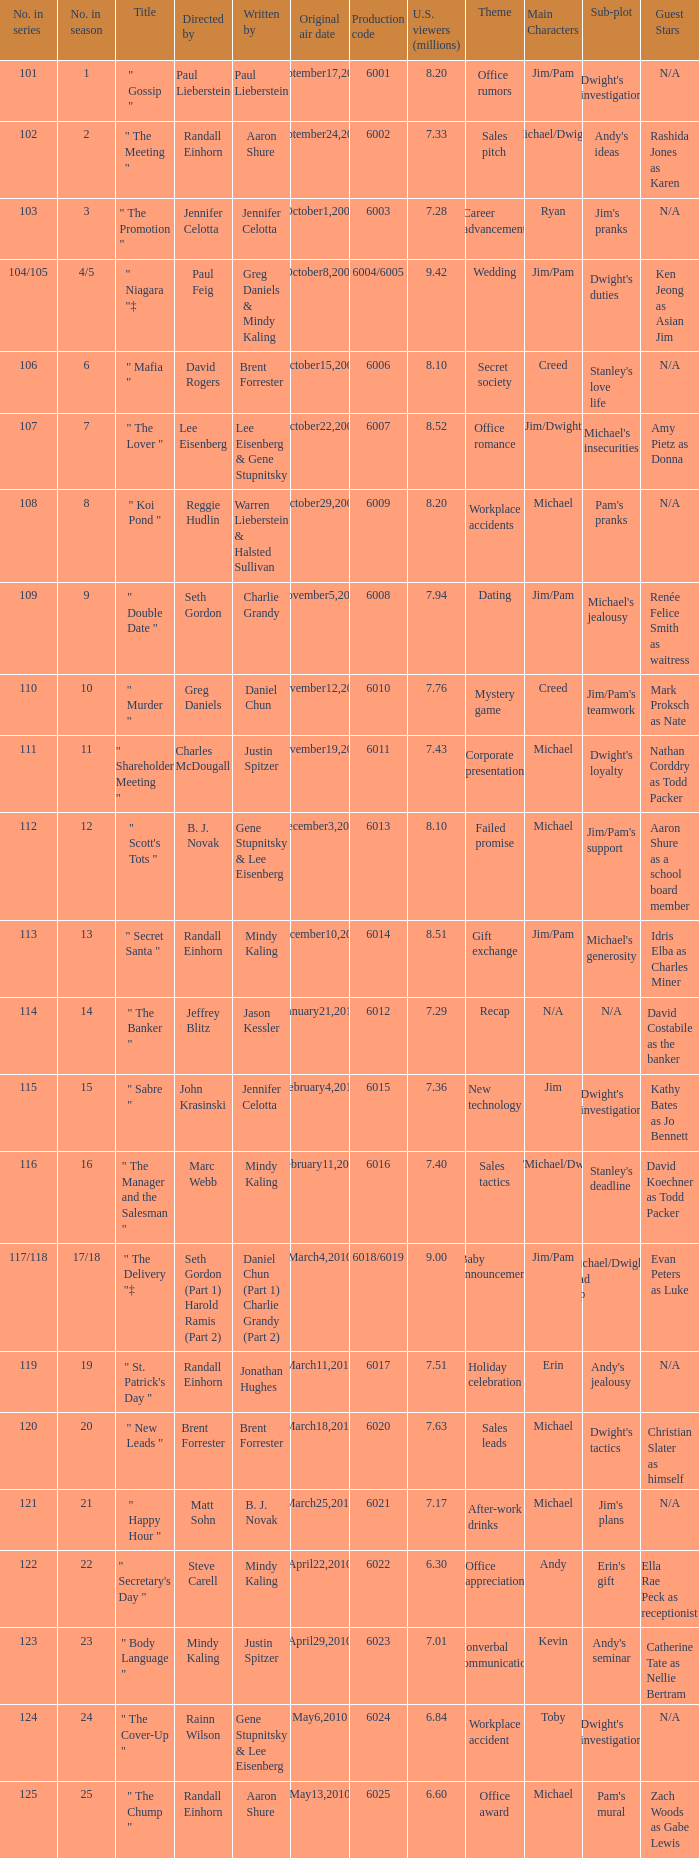Name the production code by paul lieberstein 6001.0. 